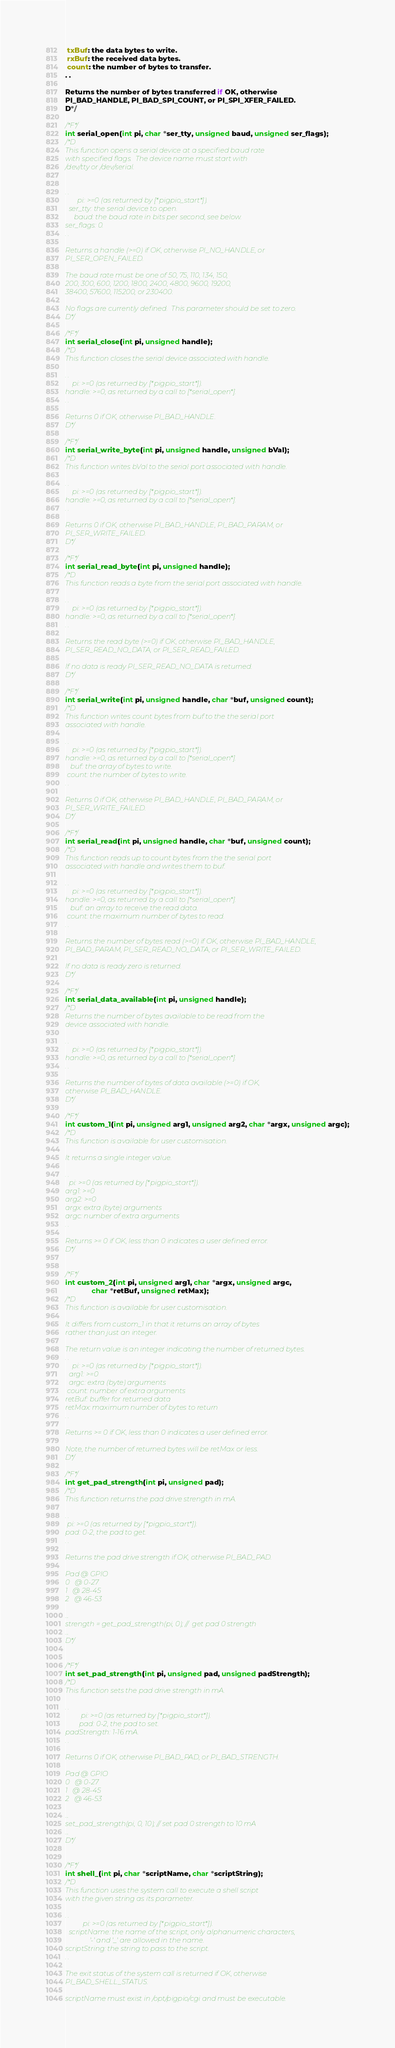Convert code to text. <code><loc_0><loc_0><loc_500><loc_500><_C_> txBuf: the data bytes to write.
 rxBuf: the received data bytes.
 count: the number of bytes to transfer.
. .

Returns the number of bytes transferred if OK, otherwise
PI_BAD_HANDLE, PI_BAD_SPI_COUNT, or PI_SPI_XFER_FAILED.
D*/

/*F*/
int serial_open(int pi, char *ser_tty, unsigned baud, unsigned ser_flags);
/*D
This function opens a serial device at a specified baud rate
with specified flags.  The device name must start with
/dev/tty or /dev/serial.


. .
       pi: >=0 (as returned by [*pigpio_start*]).
  ser_tty: the serial device to open.
     baud: the baud rate in bits per second, see below.
ser_flags: 0.
. .

Returns a handle (>=0) if OK, otherwise PI_NO_HANDLE, or
PI_SER_OPEN_FAILED.

The baud rate must be one of 50, 75, 110, 134, 150,
200, 300, 600, 1200, 1800, 2400, 4800, 9600, 19200,
38400, 57600, 115200, or 230400.

No flags are currently defined.  This parameter should be set to zero.
D*/

/*F*/
int serial_close(int pi, unsigned handle);
/*D
This function closes the serial device associated with handle.

. .
    pi: >=0 (as returned by [*pigpio_start*]).
handle: >=0, as returned by a call to [*serial_open*].
. .

Returns 0 if OK, otherwise PI_BAD_HANDLE.
D*/

/*F*/
int serial_write_byte(int pi, unsigned handle, unsigned bVal);
/*D
This function writes bVal to the serial port associated with handle.

. .
    pi: >=0 (as returned by [*pigpio_start*]).
handle: >=0, as returned by a call to [*serial_open*].
. .

Returns 0 if OK, otherwise PI_BAD_HANDLE, PI_BAD_PARAM, or
PI_SER_WRITE_FAILED.
D*/

/*F*/
int serial_read_byte(int pi, unsigned handle);
/*D
This function reads a byte from the serial port associated with handle.

. .
    pi: >=0 (as returned by [*pigpio_start*]).
handle: >=0, as returned by a call to [*serial_open*].
. .

Returns the read byte (>=0) if OK, otherwise PI_BAD_HANDLE,
PI_SER_READ_NO_DATA, or PI_SER_READ_FAILED.

If no data is ready PI_SER_READ_NO_DATA is returned.
D*/

/*F*/
int serial_write(int pi, unsigned handle, char *buf, unsigned count);
/*D
This function writes count bytes from buf to the the serial port
associated with handle.

. .
    pi: >=0 (as returned by [*pigpio_start*]).
handle: >=0, as returned by a call to [*serial_open*].
   buf: the array of bytes to write.
 count: the number of bytes to write.
. .

Returns 0 if OK, otherwise PI_BAD_HANDLE, PI_BAD_PARAM, or
PI_SER_WRITE_FAILED.
D*/

/*F*/
int serial_read(int pi, unsigned handle, char *buf, unsigned count);
/*D
This function reads up to count bytes from the the serial port
associated with handle and writes them to buf.

. .
    pi: >=0 (as returned by [*pigpio_start*]).
handle: >=0, as returned by a call to [*serial_open*].
   buf: an array to receive the read data.
 count: the maximum number of bytes to read.
. .

Returns the number of bytes read (>=0) if OK, otherwise PI_BAD_HANDLE,
PI_BAD_PARAM, PI_SER_READ_NO_DATA, or PI_SER_WRITE_FAILED.

If no data is ready zero is returned.
D*/

/*F*/
int serial_data_available(int pi, unsigned handle);
/*D
Returns the number of bytes available to be read from the
device associated with handle.

. .
    pi: >=0 (as returned by [*pigpio_start*]).
handle: >=0, as returned by a call to [*serial_open*].
. .

Returns the number of bytes of data available (>=0) if OK,
otherwise PI_BAD_HANDLE.
D*/

/*F*/
int custom_1(int pi, unsigned arg1, unsigned arg2, char *argx, unsigned argc);
/*D
This function is available for user customisation.

It returns a single integer value.

. .
  pi: >=0 (as returned by [*pigpio_start*]).
arg1: >=0
arg2: >=0
argx: extra (byte) arguments
argc: number of extra arguments
. .

Returns >= 0 if OK, less than 0 indicates a user defined error.
D*/


/*F*/
int custom_2(int pi, unsigned arg1, char *argx, unsigned argc,
             char *retBuf, unsigned retMax);
/*D
This function is available for user customisation.

It differs from custom_1 in that it returns an array of bytes
rather than just an integer.

The return value is an integer indicating the number of returned bytes.
. .
    pi: >=0 (as returned by [*pigpio_start*]).
  arg1: >=0
  argc: extra (byte) arguments
 count: number of extra arguments
retBuf: buffer for returned data
retMax: maximum number of bytes to return
. .

Returns >= 0 if OK, less than 0 indicates a user defined error.

Note, the number of returned bytes will be retMax or less.
D*/

/*F*/
int get_pad_strength(int pi, unsigned pad);
/*D
This function returns the pad drive strength in mA.

. .
 pi: >=0 (as returned by [*pigpio_start*]).
pad: 0-2, the pad to get.
. .

Returns the pad drive strength if OK, otherwise PI_BAD_PAD.

Pad @ GPIO
0   @ 0-27
1   @ 28-45
2   @ 46-53

...
strength = get_pad_strength(pi, 0); //  get pad 0 strength
...
D*/


/*F*/
int set_pad_strength(int pi, unsigned pad, unsigned padStrength);
/*D
This function sets the pad drive strength in mA.

. .
         pi: >=0 (as returned by [*pigpio_start*]).
        pad: 0-2, the pad to set.
padStrength: 1-16 mA.
. .

Returns 0 if OK, otherwise PI_BAD_PAD, or PI_BAD_STRENGTH.

Pad @ GPIO
0   @ 0-27
1   @ 28-45
2   @ 46-53

...
set_pad_strength(pi, 0, 10); // set pad 0 strength to 10 mA
...
D*/


/*F*/
int shell_(int pi, char *scriptName, char *scriptString);
/*D
This function uses the system call to execute a shell script
with the given string as its parameter.

. .
          pi: >=0 (as returned by [*pigpio_start*]).
  scriptName: the name of the script, only alphanumeric characters,
              '-' and '_' are allowed in the name.
scriptString: the string to pass to the script.
. .

The exit status of the system call is returned if OK, otherwise
PI_BAD_SHELL_STATUS.

scriptName must exist in /opt/pigpio/cgi and must be executable.
</code> 